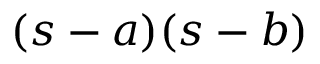Convert formula to latex. <formula><loc_0><loc_0><loc_500><loc_500>( s - a ) ( s - b )</formula> 